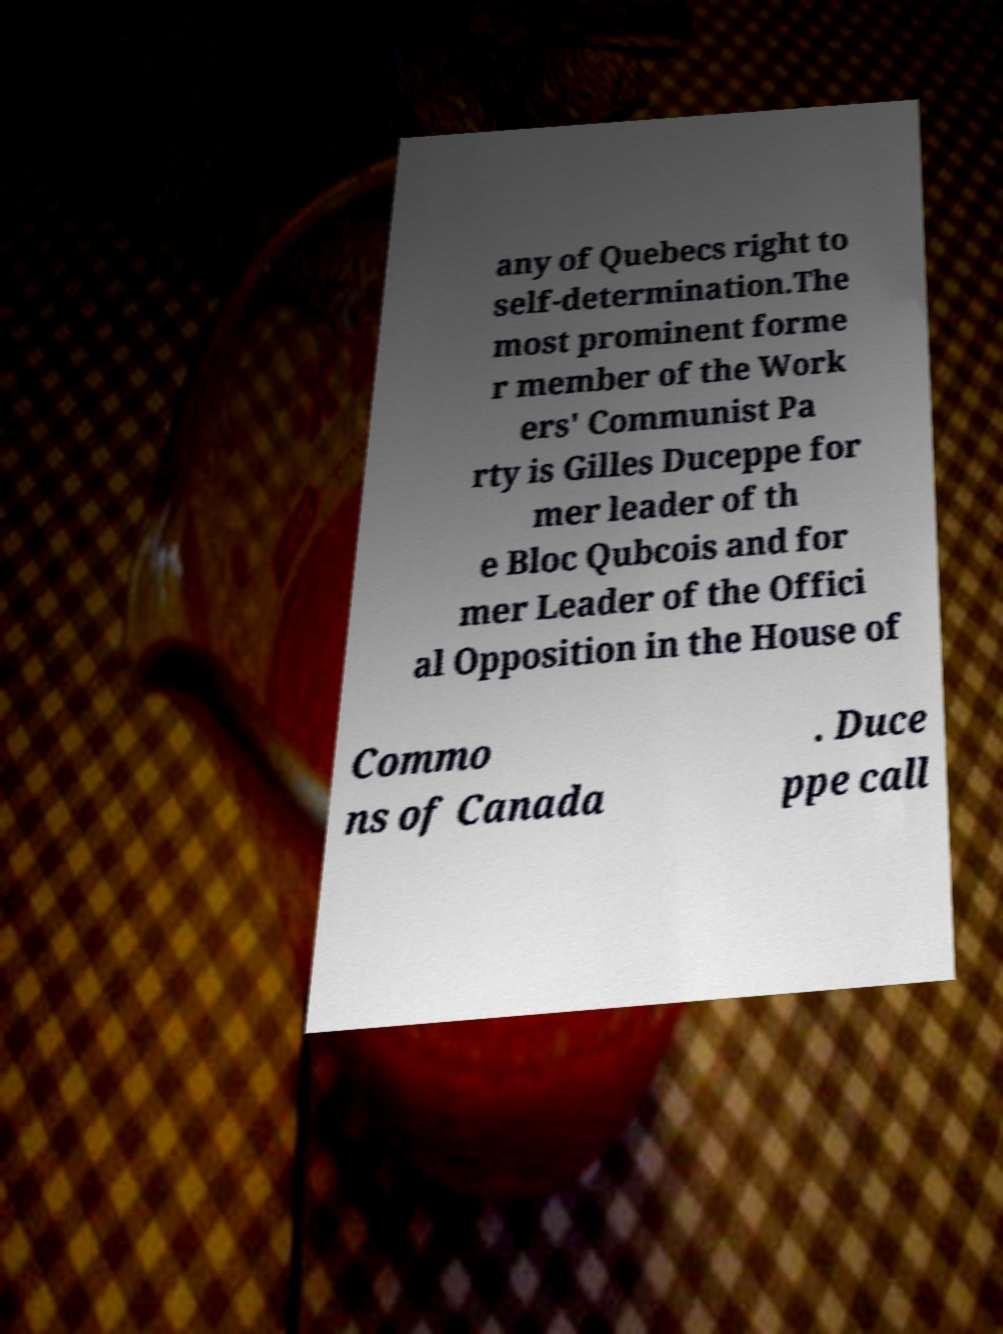Can you accurately transcribe the text from the provided image for me? any of Quebecs right to self-determination.The most prominent forme r member of the Work ers' Communist Pa rty is Gilles Duceppe for mer leader of th e Bloc Qubcois and for mer Leader of the Offici al Opposition in the House of Commo ns of Canada . Duce ppe call 